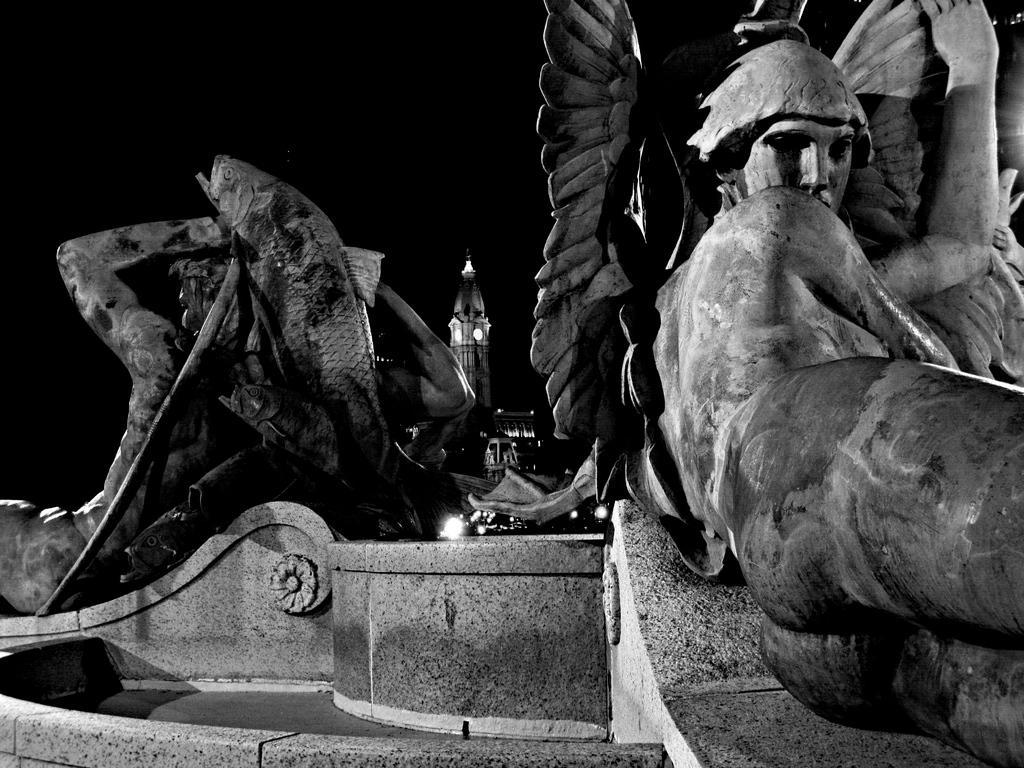In one or two sentences, can you explain what this image depicts? It is a black and white image. In this image we can see the depiction of humans and also the fish. In the background we can see the lights and also the tower building. 